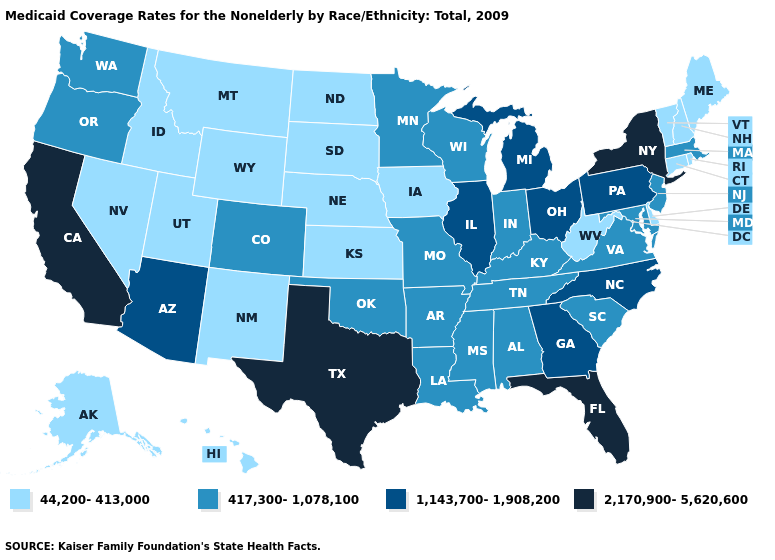Name the states that have a value in the range 44,200-413,000?
Answer briefly. Alaska, Connecticut, Delaware, Hawaii, Idaho, Iowa, Kansas, Maine, Montana, Nebraska, Nevada, New Hampshire, New Mexico, North Dakota, Rhode Island, South Dakota, Utah, Vermont, West Virginia, Wyoming. What is the value of South Carolina?
Quick response, please. 417,300-1,078,100. What is the value of Connecticut?
Quick response, please. 44,200-413,000. What is the value of Iowa?
Answer briefly. 44,200-413,000. Name the states that have a value in the range 2,170,900-5,620,600?
Give a very brief answer. California, Florida, New York, Texas. Which states have the lowest value in the MidWest?
Write a very short answer. Iowa, Kansas, Nebraska, North Dakota, South Dakota. What is the value of California?
Concise answer only. 2,170,900-5,620,600. What is the lowest value in the USA?
Keep it brief. 44,200-413,000. Which states hav the highest value in the Northeast?
Short answer required. New York. What is the highest value in the USA?
Keep it brief. 2,170,900-5,620,600. Does West Virginia have the highest value in the USA?
Short answer required. No. Does Missouri have a lower value than Arizona?
Short answer required. Yes. Name the states that have a value in the range 1,143,700-1,908,200?
Answer briefly. Arizona, Georgia, Illinois, Michigan, North Carolina, Ohio, Pennsylvania. What is the lowest value in the USA?
Concise answer only. 44,200-413,000. Does New Hampshire have a lower value than Tennessee?
Give a very brief answer. Yes. 